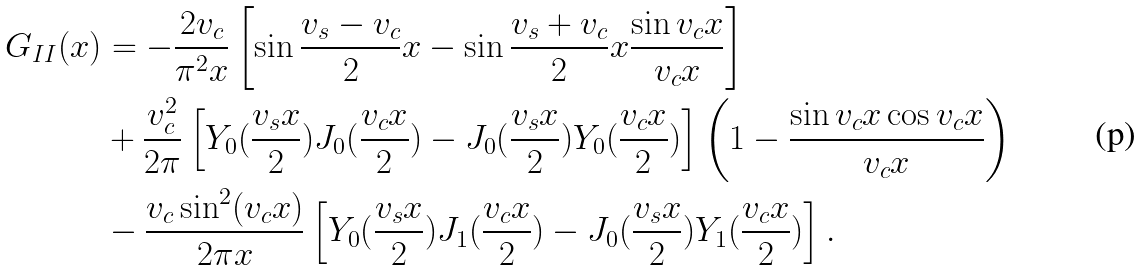Convert formula to latex. <formula><loc_0><loc_0><loc_500><loc_500>G _ { I I } ( x ) & = - \frac { 2 v _ { c } } { \pi ^ { 2 } x } \left [ \sin \frac { v _ { s } - v _ { c } } { 2 } x - \sin \frac { v _ { s } + v _ { c } } { 2 } x \frac { \sin v _ { c } x } { v _ { c } x } \right ] \\ & + \frac { v _ { c } ^ { 2 } } { 2 \pi } \left [ Y _ { 0 } ( \frac { v _ { s } x } { 2 } ) J _ { 0 } ( \frac { v _ { c } x } { 2 } ) - J _ { 0 } ( \frac { v _ { s } x } { 2 } ) Y _ { 0 } ( \frac { v _ { c } x } { 2 } ) \right ] \left ( 1 - \frac { \sin v _ { c } x \cos v _ { c } x } { v _ { c } x } \right ) \\ & - \frac { v _ { c } \sin ^ { 2 } ( v _ { c } x ) } { 2 \pi x } \left [ Y _ { 0 } ( \frac { v _ { s } x } { 2 } ) J _ { 1 } ( \frac { v _ { c } x } { 2 } ) - J _ { 0 } ( \frac { v _ { s } x } { 2 } ) Y _ { 1 } ( \frac { v _ { c } x } { 2 } ) \right ] .</formula> 